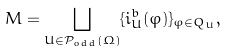<formula> <loc_0><loc_0><loc_500><loc_500>M = \bigsqcup _ { U \in \mathcal { P } _ { o d d } ( \Omega ) } \{ i _ { U } ^ { b } ( \varphi ) \} _ { \varphi \in Q _ { U } } ,</formula> 